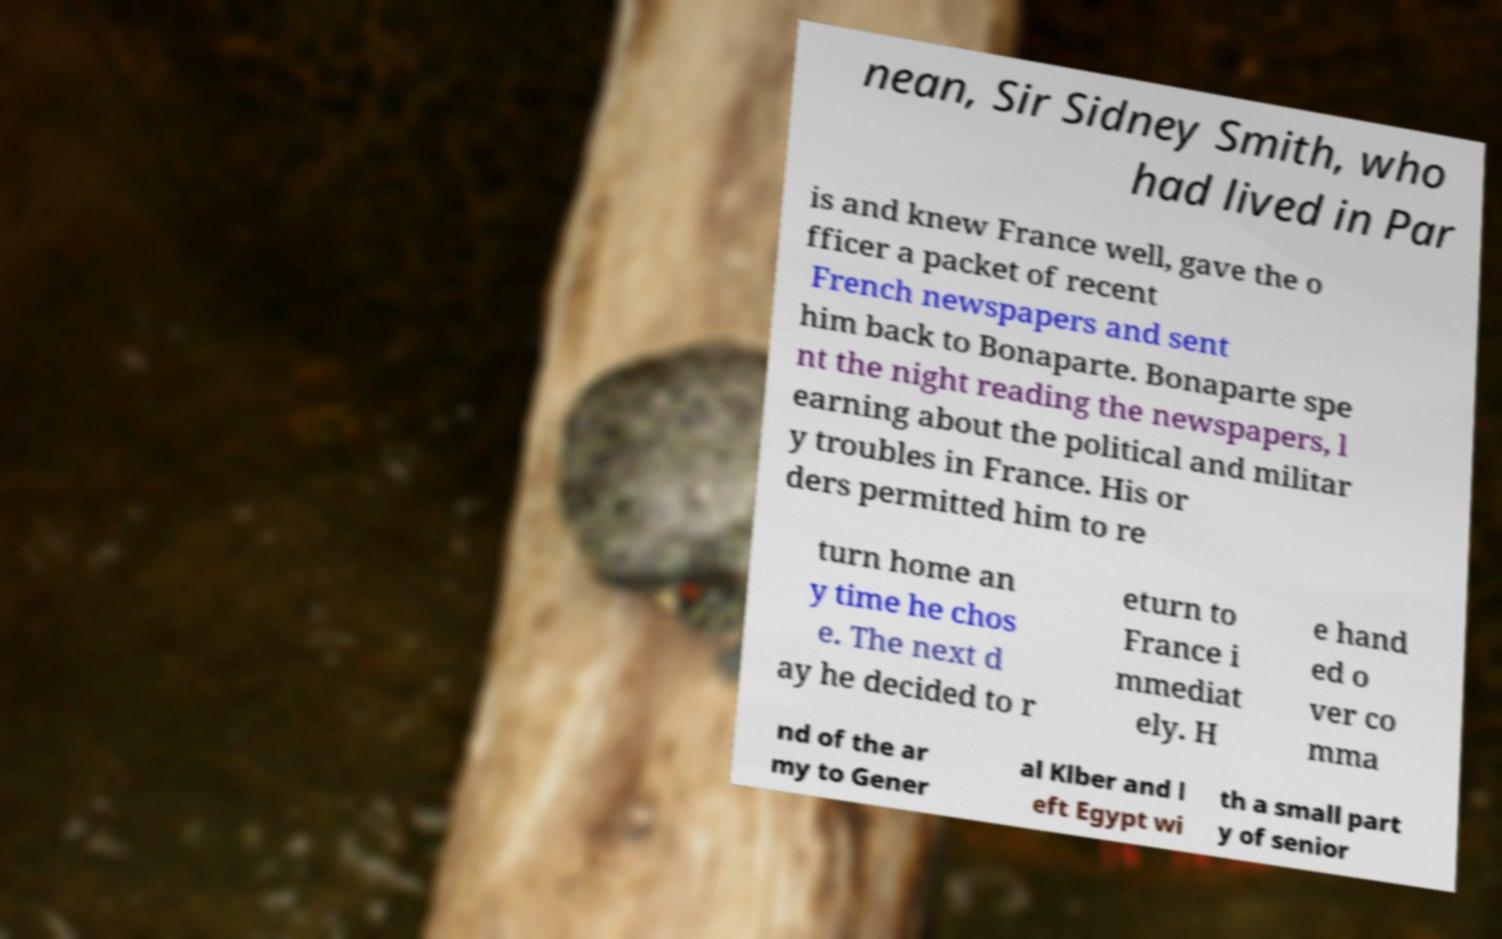For documentation purposes, I need the text within this image transcribed. Could you provide that? nean, Sir Sidney Smith, who had lived in Par is and knew France well, gave the o fficer a packet of recent French newspapers and sent him back to Bonaparte. Bonaparte spe nt the night reading the newspapers, l earning about the political and militar y troubles in France. His or ders permitted him to re turn home an y time he chos e. The next d ay he decided to r eturn to France i mmediat ely. H e hand ed o ver co mma nd of the ar my to Gener al Klber and l eft Egypt wi th a small part y of senior 